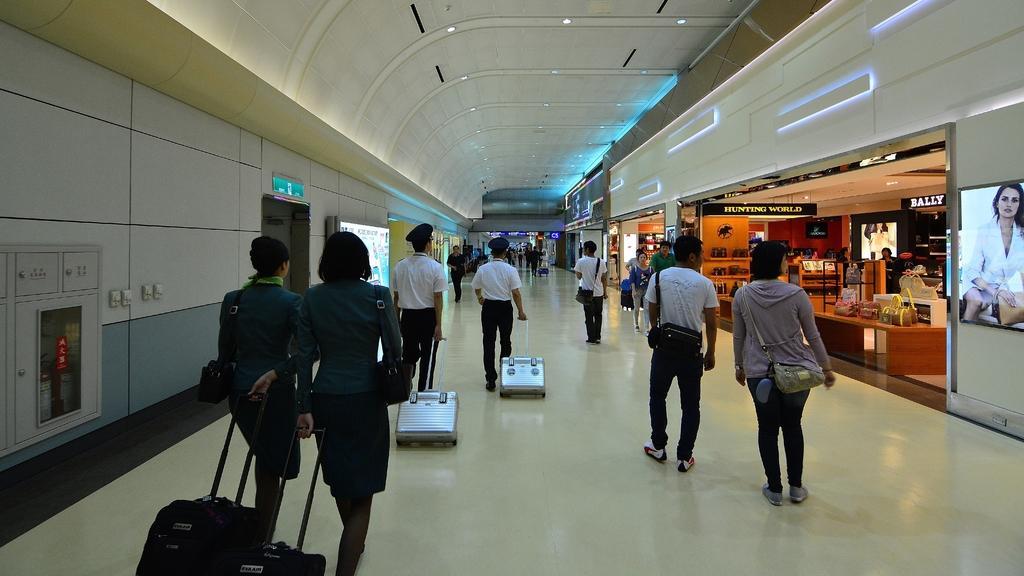How would you summarize this image in a sentence or two? there are so many people walking along with trolley in airport behind them there is a shopping store. 